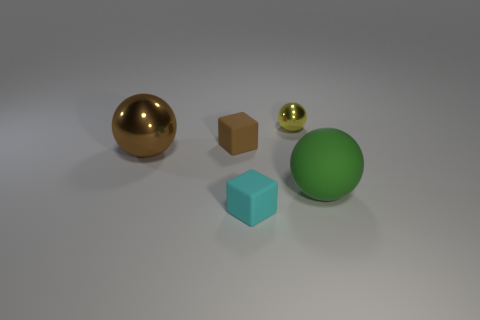What materials and colors are represented in the objects within the image? There are various materials and colors in the image. The objects include a glossy gold sphere, a matte brown cube, a shiny small green sphere, a matte large green sphere, and a small cyan rubber-like block. 